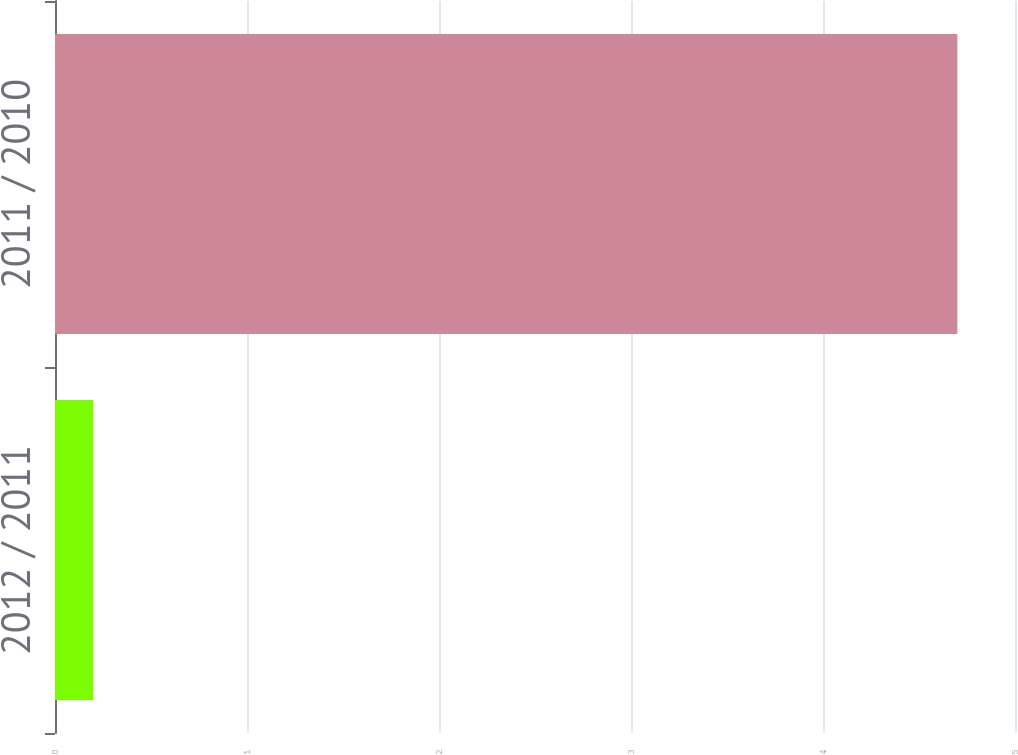Convert chart to OTSL. <chart><loc_0><loc_0><loc_500><loc_500><bar_chart><fcel>2012 / 2011<fcel>2011 / 2010<nl><fcel>0.2<fcel>4.7<nl></chart> 